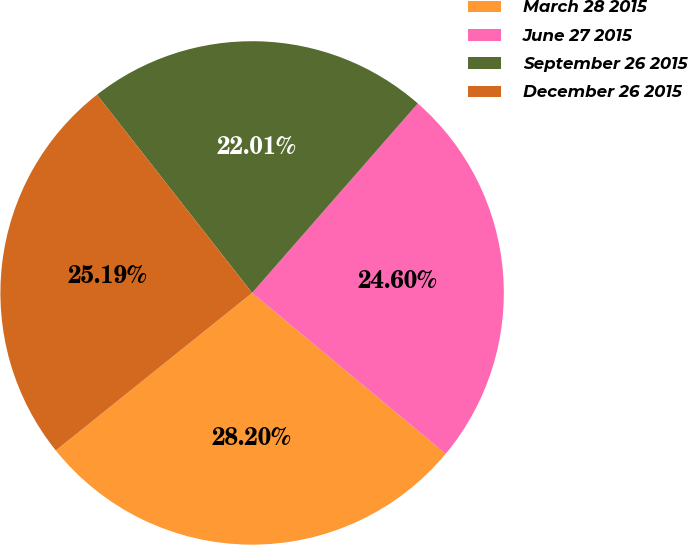<chart> <loc_0><loc_0><loc_500><loc_500><pie_chart><fcel>March 28 2015<fcel>June 27 2015<fcel>September 26 2015<fcel>December 26 2015<nl><fcel>28.2%<fcel>24.6%<fcel>22.01%<fcel>25.19%<nl></chart> 